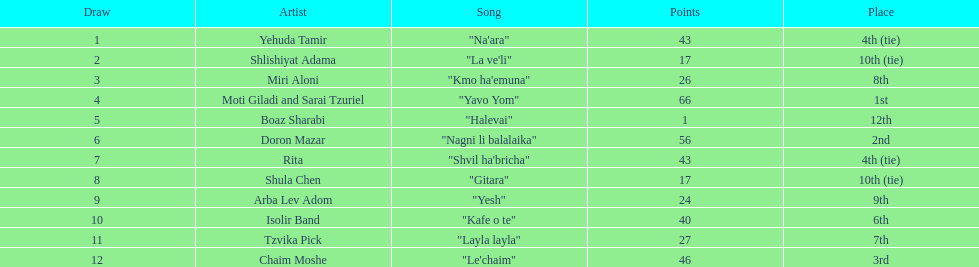What is the place of the contestant who received only 1 point? 12th. What is the name of the artist listed in the previous question? Boaz Sharabi. 